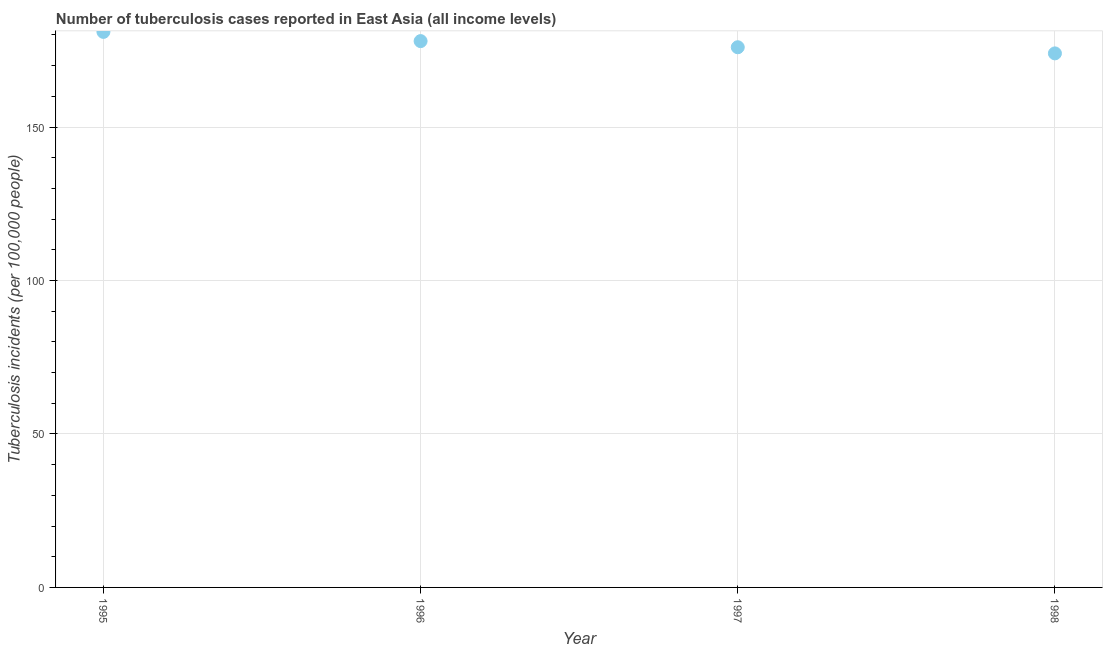What is the number of tuberculosis incidents in 1995?
Offer a terse response. 181. Across all years, what is the maximum number of tuberculosis incidents?
Make the answer very short. 181. Across all years, what is the minimum number of tuberculosis incidents?
Your answer should be very brief. 174. In which year was the number of tuberculosis incidents maximum?
Offer a terse response. 1995. In which year was the number of tuberculosis incidents minimum?
Make the answer very short. 1998. What is the sum of the number of tuberculosis incidents?
Your answer should be very brief. 709. What is the difference between the number of tuberculosis incidents in 1996 and 1997?
Your answer should be very brief. 2. What is the average number of tuberculosis incidents per year?
Your answer should be compact. 177.25. What is the median number of tuberculosis incidents?
Provide a succinct answer. 177. Do a majority of the years between 1998 and 1996 (inclusive) have number of tuberculosis incidents greater than 130 ?
Offer a terse response. No. What is the ratio of the number of tuberculosis incidents in 1997 to that in 1998?
Your answer should be very brief. 1.01. What is the difference between the highest and the second highest number of tuberculosis incidents?
Give a very brief answer. 3. Is the sum of the number of tuberculosis incidents in 1995 and 1996 greater than the maximum number of tuberculosis incidents across all years?
Keep it short and to the point. Yes. What is the difference between the highest and the lowest number of tuberculosis incidents?
Offer a very short reply. 7. How many years are there in the graph?
Your answer should be very brief. 4. Are the values on the major ticks of Y-axis written in scientific E-notation?
Give a very brief answer. No. Does the graph contain grids?
Provide a short and direct response. Yes. What is the title of the graph?
Your answer should be compact. Number of tuberculosis cases reported in East Asia (all income levels). What is the label or title of the X-axis?
Your response must be concise. Year. What is the label or title of the Y-axis?
Make the answer very short. Tuberculosis incidents (per 100,0 people). What is the Tuberculosis incidents (per 100,000 people) in 1995?
Your answer should be very brief. 181. What is the Tuberculosis incidents (per 100,000 people) in 1996?
Make the answer very short. 178. What is the Tuberculosis incidents (per 100,000 people) in 1997?
Your answer should be very brief. 176. What is the Tuberculosis incidents (per 100,000 people) in 1998?
Your answer should be compact. 174. What is the difference between the Tuberculosis incidents (per 100,000 people) in 1995 and 1996?
Provide a short and direct response. 3. What is the difference between the Tuberculosis incidents (per 100,000 people) in 1995 and 1998?
Make the answer very short. 7. What is the difference between the Tuberculosis incidents (per 100,000 people) in 1997 and 1998?
Ensure brevity in your answer.  2. What is the ratio of the Tuberculosis incidents (per 100,000 people) in 1995 to that in 1996?
Your response must be concise. 1.02. What is the ratio of the Tuberculosis incidents (per 100,000 people) in 1995 to that in 1997?
Ensure brevity in your answer.  1.03. What is the ratio of the Tuberculosis incidents (per 100,000 people) in 1995 to that in 1998?
Provide a succinct answer. 1.04. What is the ratio of the Tuberculosis incidents (per 100,000 people) in 1996 to that in 1997?
Keep it short and to the point. 1.01. 